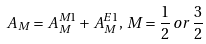Convert formula to latex. <formula><loc_0><loc_0><loc_500><loc_500>A _ { M } = A _ { M } ^ { M 1 } + A _ { M } ^ { E 1 } , \, M = \frac { 1 } { 2 } \, o r \, \frac { 3 } { 2 }</formula> 